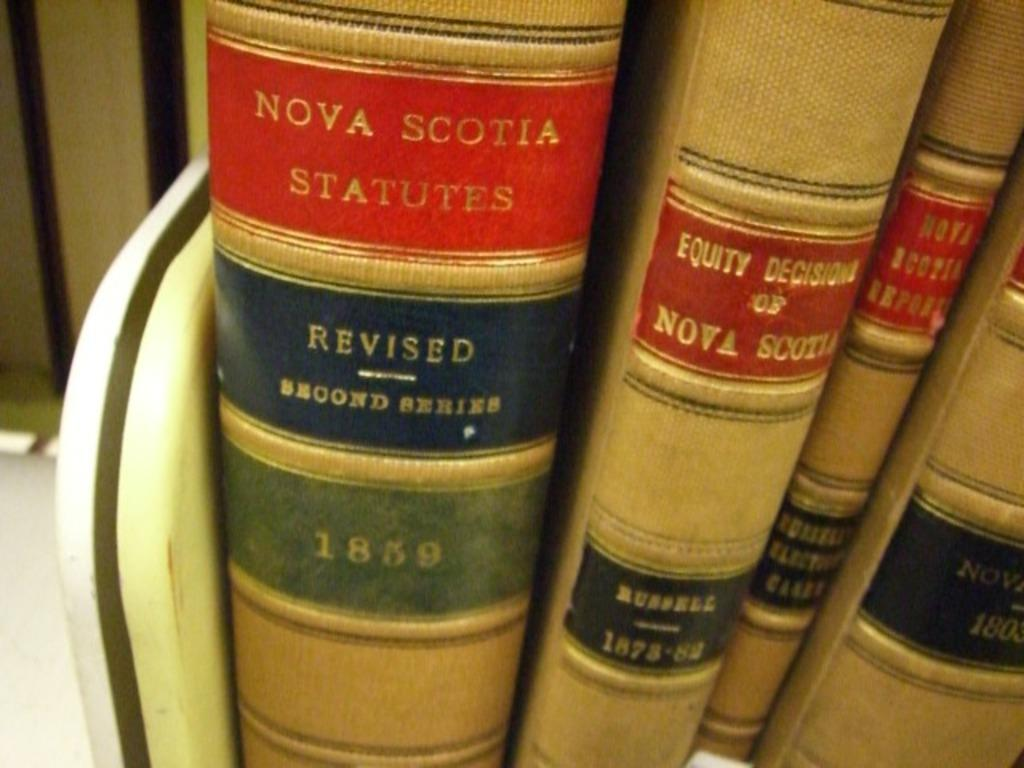<image>
Present a compact description of the photo's key features. Several books about Nova Scotia are lined up on a library shelf 